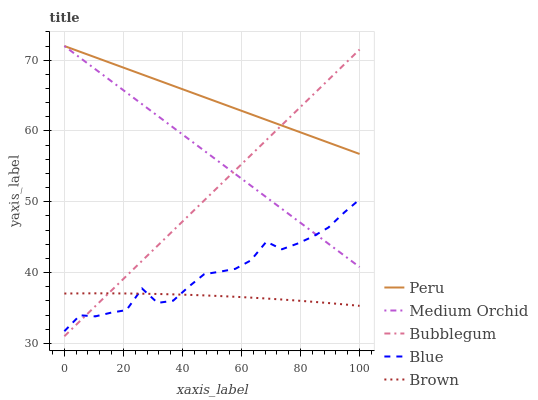Does Brown have the minimum area under the curve?
Answer yes or no. Yes. Does Peru have the maximum area under the curve?
Answer yes or no. Yes. Does Medium Orchid have the minimum area under the curve?
Answer yes or no. No. Does Medium Orchid have the maximum area under the curve?
Answer yes or no. No. Is Medium Orchid the smoothest?
Answer yes or no. Yes. Is Blue the roughest?
Answer yes or no. Yes. Is Brown the smoothest?
Answer yes or no. No. Is Brown the roughest?
Answer yes or no. No. Does Brown have the lowest value?
Answer yes or no. No. Does Peru have the highest value?
Answer yes or no. Yes. Does Brown have the highest value?
Answer yes or no. No. Is Blue less than Peru?
Answer yes or no. Yes. Is Medium Orchid greater than Brown?
Answer yes or no. Yes. Does Peru intersect Medium Orchid?
Answer yes or no. Yes. Is Peru less than Medium Orchid?
Answer yes or no. No. Is Peru greater than Medium Orchid?
Answer yes or no. No. Does Blue intersect Peru?
Answer yes or no. No. 